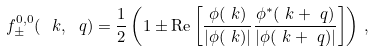<formula> <loc_0><loc_0><loc_500><loc_500>f _ { \pm } ^ { 0 , 0 } ( \ k , \ q ) & = \frac { 1 } { 2 } \left ( 1 \pm \text {Re} \left [ \frac { \phi ( \ k ) } { | \phi ( \ k ) | } \frac { \phi ^ { * } ( \ k + \ q ) } { | \phi ( \ k + \ q ) | } \right ] \right ) \, ,</formula> 